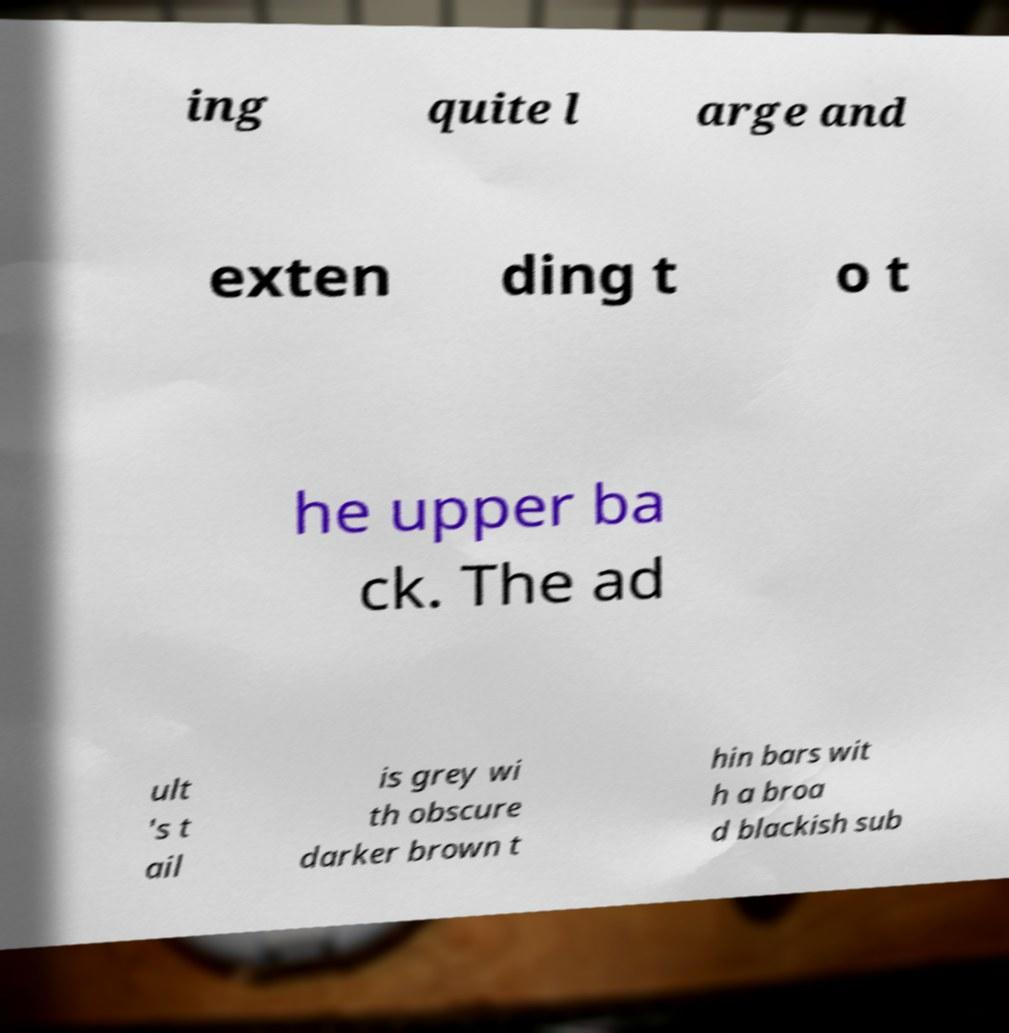What messages or text are displayed in this image? I need them in a readable, typed format. ing quite l arge and exten ding t o t he upper ba ck. The ad ult 's t ail is grey wi th obscure darker brown t hin bars wit h a broa d blackish sub 